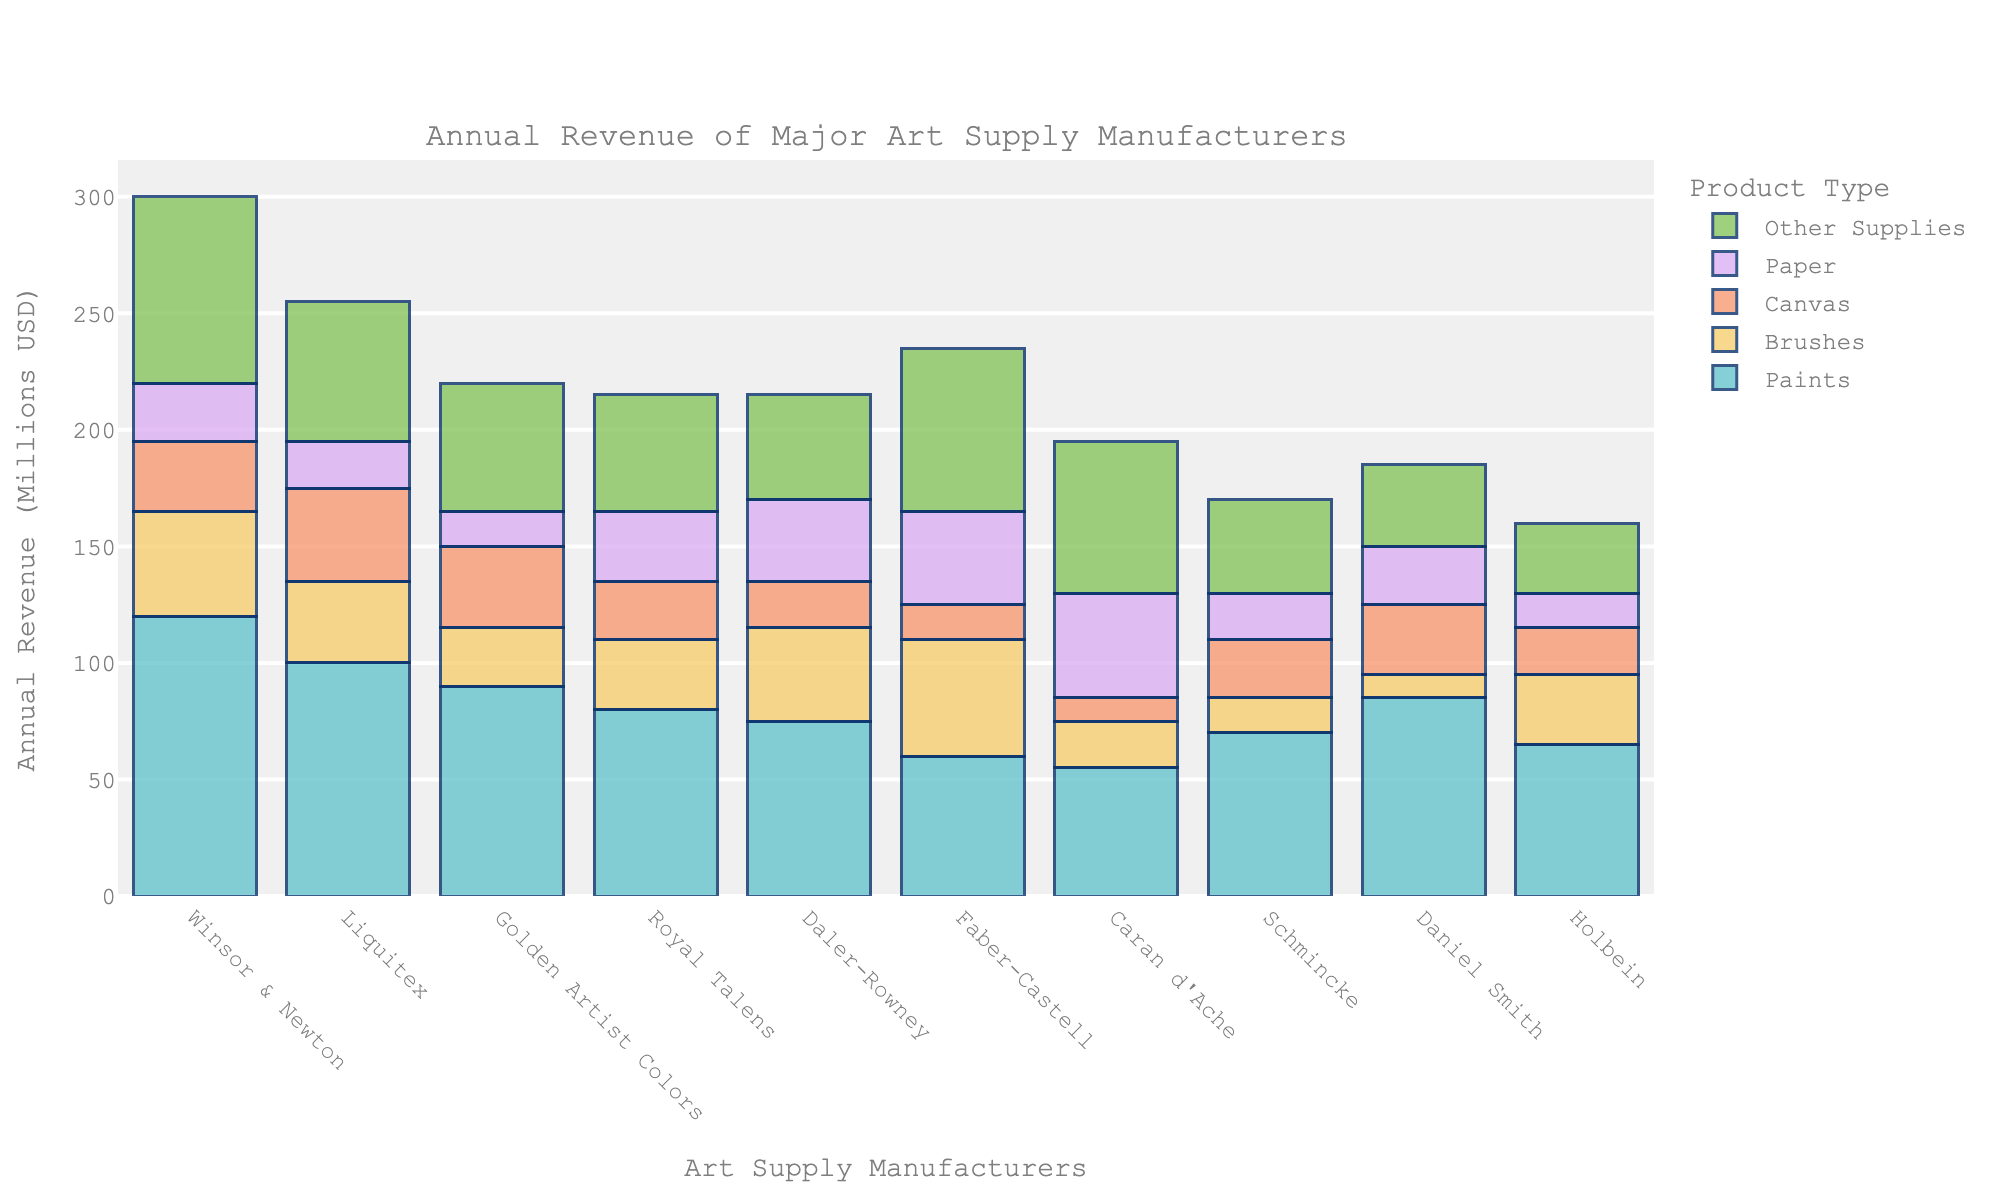Which company has the highest total revenue? To determine the company with the highest total revenue, add up the revenues for all product categories (Paints, Brushes, Canvas, Paper, Other Supplies) for each company. The company with the highest sum will be the answer. Winsor & Newton: 120+45+30+25+80 = 300; Liquitex: 100+35+40+20+60 = 255; Golden Artist Colors: 90+25+35+15+55 = 220; Royal Talens: 80+30+25+30+50 = 215; Daler-Rowney: 75+40+20+35+45 = 215; Faber-Castell: 60+50+15+40+70 = 235; Caran d'Ache: 55+20+10+45+65 = 195; Schmincke: 70+15+25+20+40 = 170; Daniel Smith: 85+10+30+25+35 = 185; Holbein: 65+30+20+15+30 = 160. Thus, Winsor & Newton has the highest total revenue.
Answer: Winsor & Newton Which product type generates the highest total revenue across all companies? To determine the highest revenue-generating product type, sum the revenue for each product category across all companies. Paints: 120+100+90+80+75+60+55+70+85+65 = 800; Brushes: 45+35+25+30+40+50+20+15+10+30 = 300; Canvas: 30+40+35+25+20+15+10+25+30+20 = 250; Paper: 25+20+15+30+35+40+45+20+25+15 = 270; Other Supplies: 80+60+55+50+45+70+65+40+35+30 = 530. Thus, Paints generate the highest total revenue.
Answer: Paints What is the average revenue for Brushes among all companies? To calculate the average revenue for Brushes, first sum the revenue from all companies for Brushes and then divide by the number of companies. Brushes: 45+35+25+30+40+50+20+15+10+30 = 300; Number of companies: 10. Average = 300/10 = 30.
Answer: 30 Which company has the highest revenue from Paper? To find the company with the highest revenue from Paper, compare the Paper revenue across all companies. Winsor & Newton: 25, Liquitex: 20, Golden Artist Colors: 15, Royal Talens: 30, Daler-Rowney: 35, Faber-Castell: 40, Caran d'Ache: 45, Schmincke: 20, Daniel Smith: 25, Holbein: 15. Thus, Caran d'Ache has the highest revenue from Paper.
Answer: Caran d'Ache Which company has a higher combined revenue from Brushes and Canvas: Liquitex or Daler-Rowney? To determine which company has the higher combined revenue from Brushes and Canvas, sum the revenues from these categories for each company. Liquitex: Brushes = 35, Canvas = 40; Combined = 35+40 = 75. Daler-Rowney: Brushes = 40, Canvas = 20; Combined = 40+20 = 60. Thus, Liquitex has a higher combined revenue from Brushes and Canvas.
Answer: Liquitex Which product type consistently shows lower revenue among most companies, Paper or Other Supplies? To determine the product type with consistently lower revenue, compare the revenues for each company for Paper and Other Supplies. Winsor & Newton: Paper(25) vs Other Supplies(80), Liquitex: Paper(20) vs Other Supplies(60), Golden Artist Colors: Paper(15) vs Other Supplies(55), Royal Talens: Paper(30) vs Other Supplies(50), Daler-Rowney: Paper(35) vs Other Supplies(45), Faber-Castell: Paper(40) vs Other Supplies(70), Caran d'Ache: Paper(45) vs Other Supplies(65), Schmincke: Paper(20) vs Other Supplies(40), Daniel Smith: Paper(25) vs Other Supplies(35), Holbein: Paper(15) vs Other Supplies(30). Paper has consistently lower revenue compared to Other Supplies in most companies.
Answer: Paper How does Daniel Smith's total revenue from Canvas compare to Faber-Castell's? To compare Daniel Smith's and Faber-Castell's total revenue from Canvas, look at the respective values. Daniel Smith: 30, Faber-Castell: 15. Thus, Daniel Smith's total revenue from Canvas is higher than Faber-Castell's.
Answer: Daniel Smith What percentage of Winsor & Newton's total revenue comes from Paints? To calculate the percentage of Winsor & Newton's revenue from Paints, divide the revenue from Paints by the total revenue, then multiply by 100. Paints: 120; Total revenue: 300. Percentage = (120/300) * 100 = 40%.
Answer: 40% Which company has the lowest revenue from Brushes? To find the company with the lowest revenue from Brushes, compare the Brush revenue across all companies. Winsor & Newton: 45, Liquitex: 35, Golden Artist Colors: 25, Royal Talens: 30, Daler-Rowney: 40, Faber-Castell: 50, Caran d'Ache: 20, Schmincke: 15, Daniel Smith: 10, Holbein: 30. Thus, Daniel Smith has the lowest revenue from Brushes.
Answer: Daniel Smith 